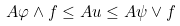<formula> <loc_0><loc_0><loc_500><loc_500>A \varphi \wedge f \leq A u \leq A \psi \vee f</formula> 